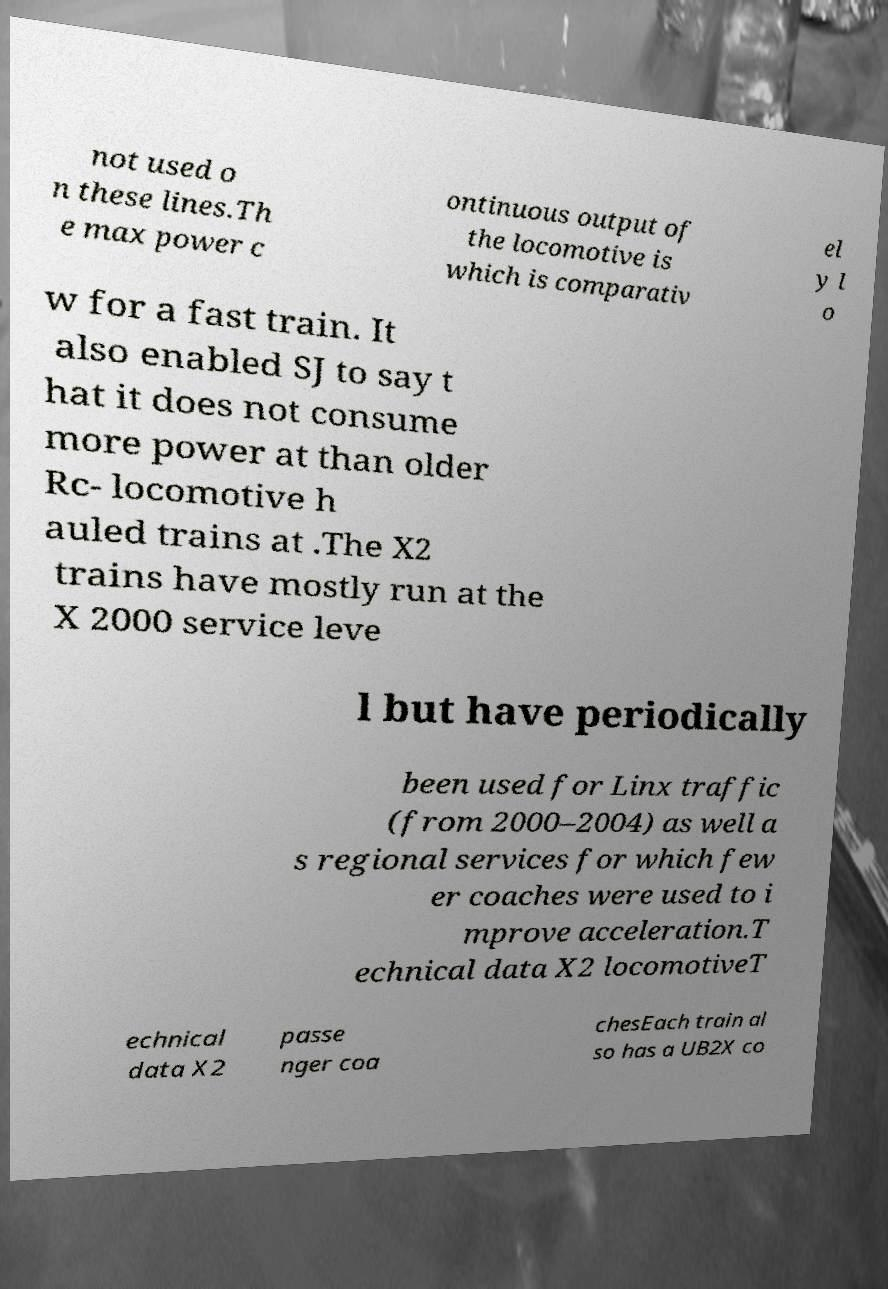There's text embedded in this image that I need extracted. Can you transcribe it verbatim? not used o n these lines.Th e max power c ontinuous output of the locomotive is which is comparativ el y l o w for a fast train. It also enabled SJ to say t hat it does not consume more power at than older Rc- locomotive h auled trains at .The X2 trains have mostly run at the X 2000 service leve l but have periodically been used for Linx traffic (from 2000–2004) as well a s regional services for which few er coaches were used to i mprove acceleration.T echnical data X2 locomotiveT echnical data X2 passe nger coa chesEach train al so has a UB2X co 